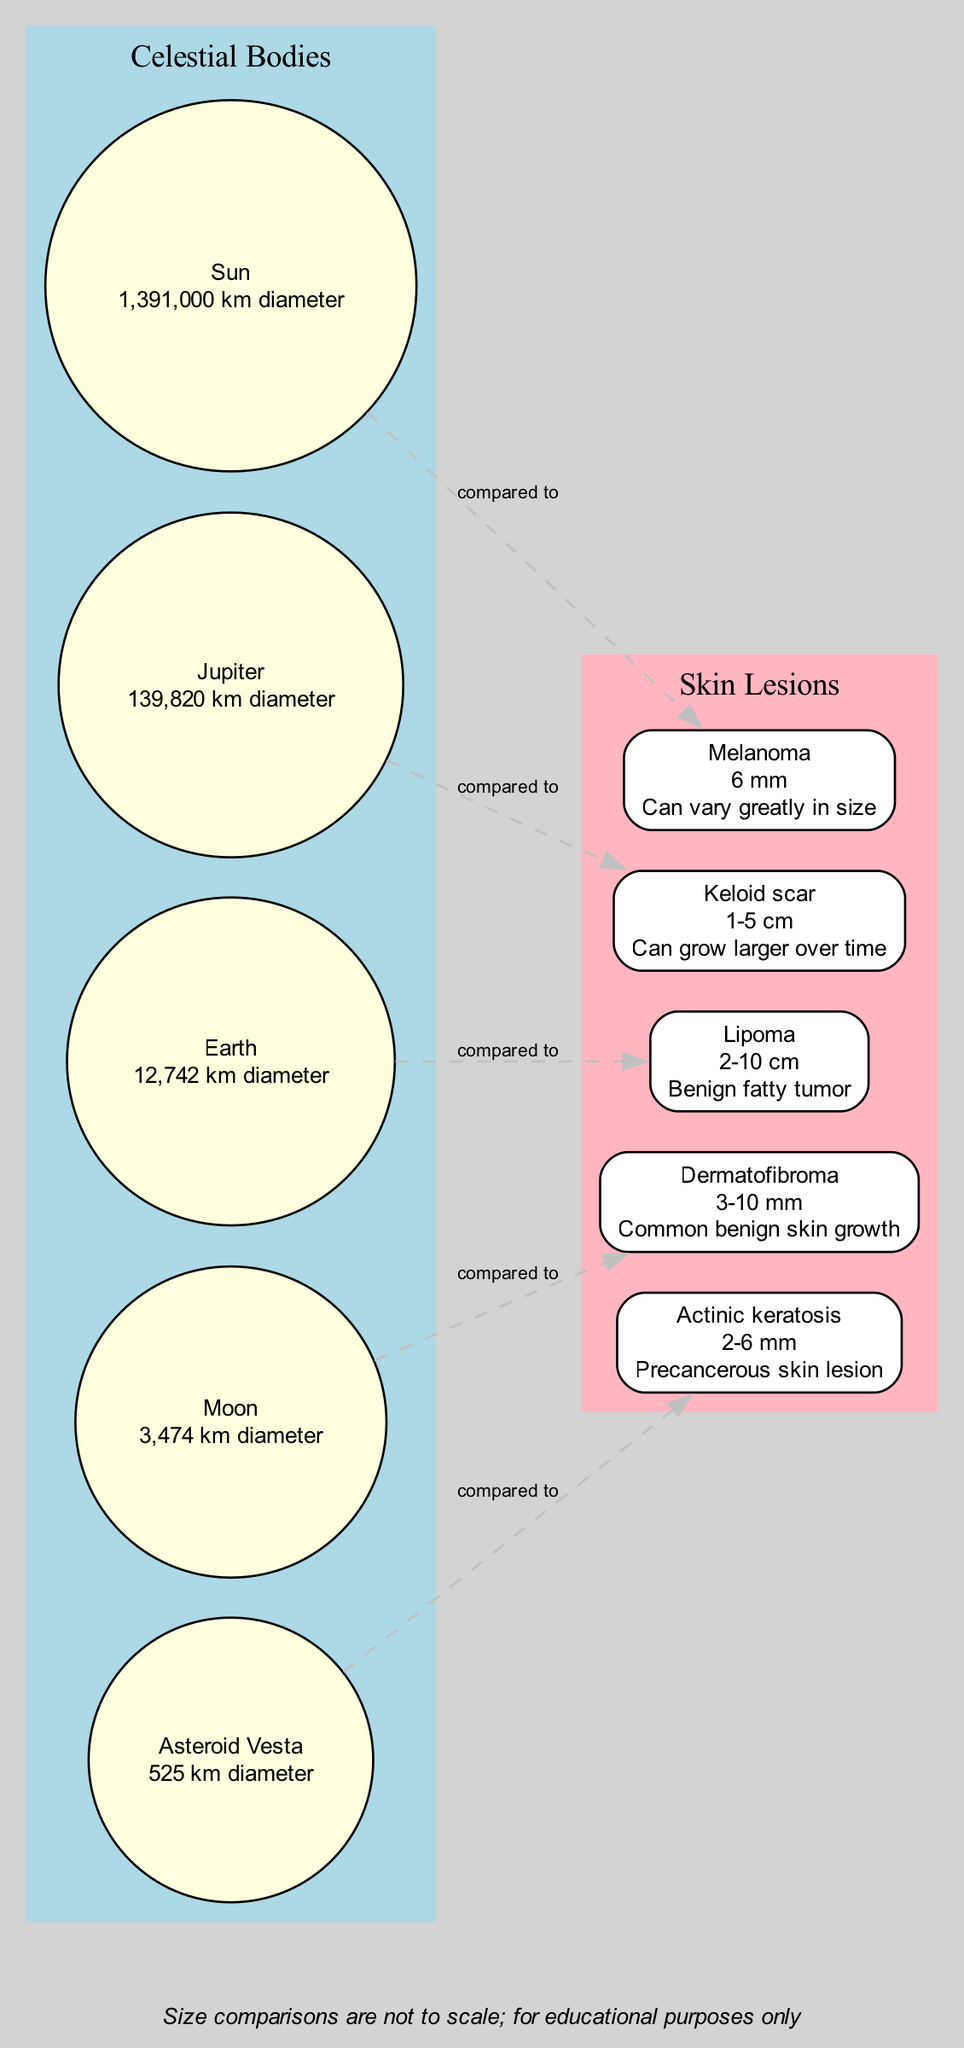What is the diameter of the Sun? The diagram indicates the size of the Sun as 1,391,000 km diameter, which is directly stated next to the Sun node in the diagram.
Answer: 1,391,000 km diameter Which skin lesion is compared to Jupiter? The diagram shows that Jupiter is compared to a Keloid scar, evidenced by the dashed edge connecting them labeled "compared to."
Answer: Keloid scar How many celestial bodies are represented in the diagram? By counting the nodes within the celestial cluster, there are five celestial bodies depicted: Sun, Jupiter, Earth, Moon, and Asteroid Vesta.
Answer: 5 What is the average size of a Lipoma? The average size of a Lipoma is noted as 2-10 cm in the Lipoma box in the skin lesions section of the diagram.
Answer: 2-10 cm Which skin lesion has a comparison with the smallest celestial body? The Moon is the smallest body represented (3,474 km diameter) and is compared to Dermatofibroma, as observed from the connecting dashed edge in the diagram.
Answer: Dermatofibroma If we consider the largest skin lesion, what is it compared to? The melanoma, which can vary greatly in size, is compared to the Sun, the largest celestial body in the diagram, shown through the connecting edge labeled "compared to."
Answer: Sun What is the average size range for Actinic keratosis? The average size for Actinic keratosis is indicated as 2-6 mm in the corresponding box, providing the specific size range directly.
Answer: 2-6 mm Which celestial body corresponds to the smallest skin lesion size in the diagram? Actinic keratosis, with an average size of 2-6 mm, corresponds to the celestial body Asteroid Vesta, as indicated by the comparison labels in the diagram.
Answer: Asteroid Vesta What is the unique note provided at the bottom of the diagram? The note at the bottom of the diagram states that size comparisons are not to scale; for educational purposes only, providing context for understanding the diagram.
Answer: Size comparisons are not to scale; for educational purposes only 